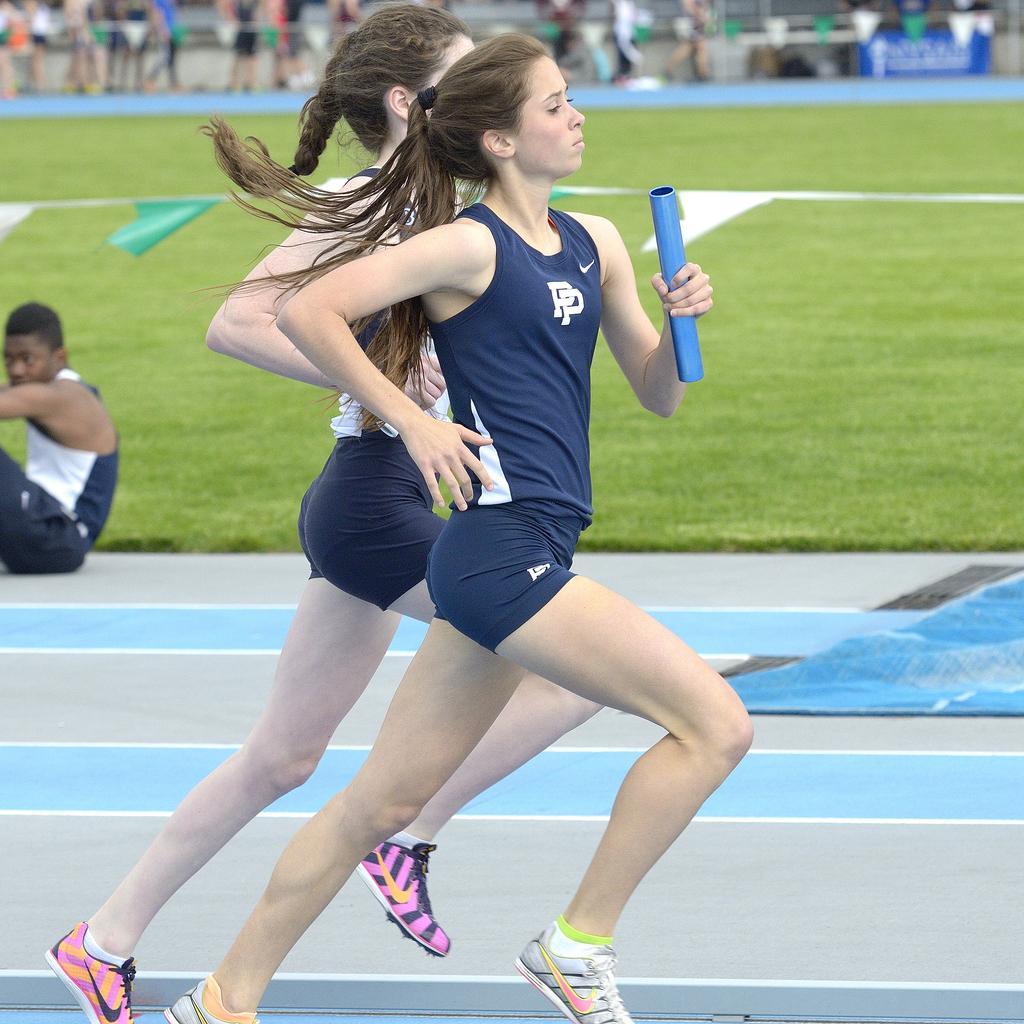Could you give a brief overview of what you see in this image? In this picture we can see two women running. In the background we can see a blue board, paper flags and people. Here we can see a man sitting on the floor. Here we can see grass. 